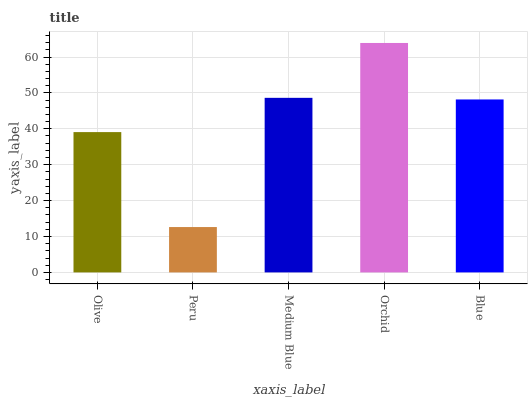Is Peru the minimum?
Answer yes or no. Yes. Is Orchid the maximum?
Answer yes or no. Yes. Is Medium Blue the minimum?
Answer yes or no. No. Is Medium Blue the maximum?
Answer yes or no. No. Is Medium Blue greater than Peru?
Answer yes or no. Yes. Is Peru less than Medium Blue?
Answer yes or no. Yes. Is Peru greater than Medium Blue?
Answer yes or no. No. Is Medium Blue less than Peru?
Answer yes or no. No. Is Blue the high median?
Answer yes or no. Yes. Is Blue the low median?
Answer yes or no. Yes. Is Orchid the high median?
Answer yes or no. No. Is Olive the low median?
Answer yes or no. No. 